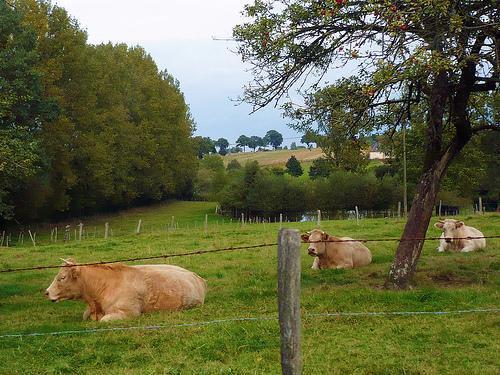How many animals are shown?
Give a very brief answer. 3. 